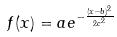Convert formula to latex. <formula><loc_0><loc_0><loc_500><loc_500>f ( x ) = a e ^ { - \frac { ( x - b ) ^ { 2 } } { 2 c ^ { 2 } } }</formula> 